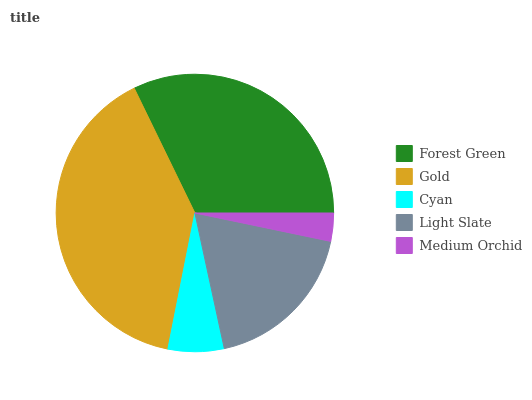Is Medium Orchid the minimum?
Answer yes or no. Yes. Is Gold the maximum?
Answer yes or no. Yes. Is Cyan the minimum?
Answer yes or no. No. Is Cyan the maximum?
Answer yes or no. No. Is Gold greater than Cyan?
Answer yes or no. Yes. Is Cyan less than Gold?
Answer yes or no. Yes. Is Cyan greater than Gold?
Answer yes or no. No. Is Gold less than Cyan?
Answer yes or no. No. Is Light Slate the high median?
Answer yes or no. Yes. Is Light Slate the low median?
Answer yes or no. Yes. Is Cyan the high median?
Answer yes or no. No. Is Cyan the low median?
Answer yes or no. No. 